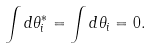<formula> <loc_0><loc_0><loc_500><loc_500>\int d \theta _ { i } ^ { * } = \int d \theta _ { i } = 0 .</formula> 